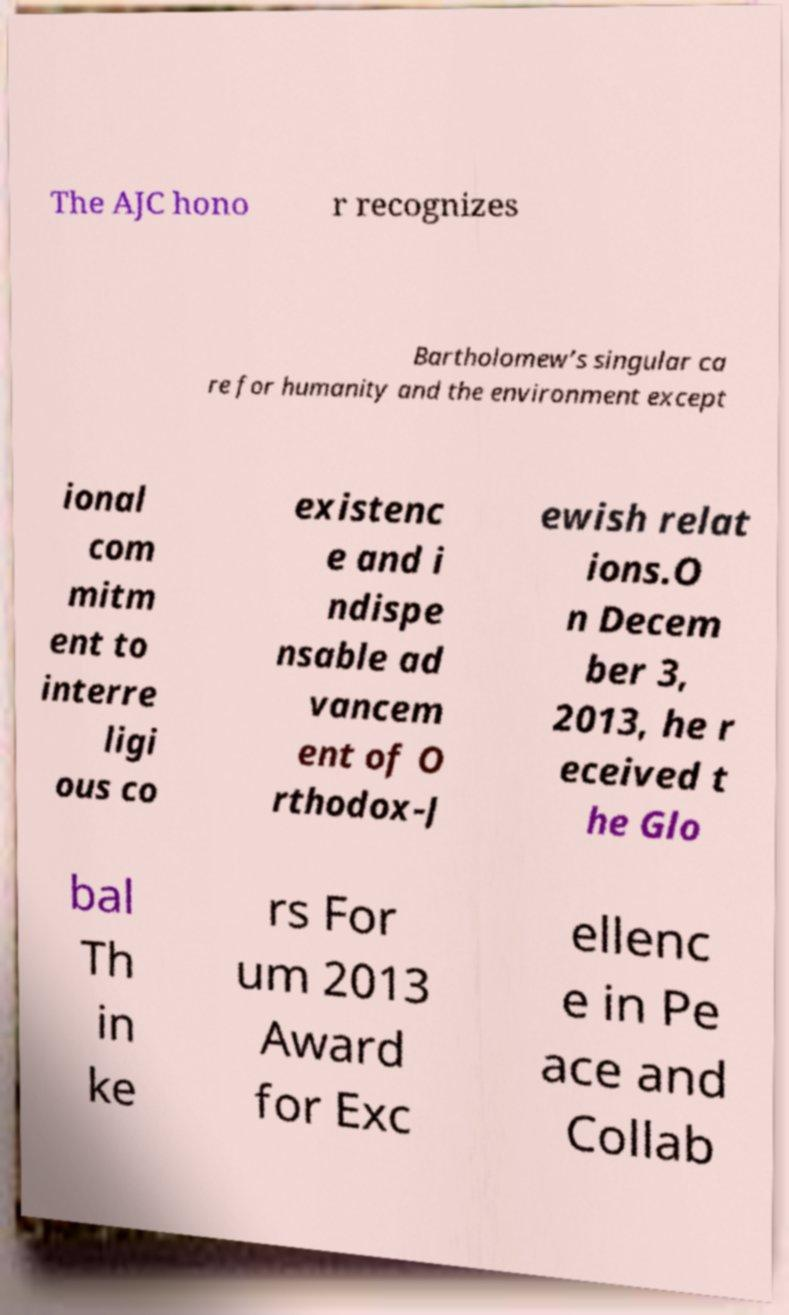Please identify and transcribe the text found in this image. The AJC hono r recognizes Bartholomew’s singular ca re for humanity and the environment except ional com mitm ent to interre ligi ous co existenc e and i ndispe nsable ad vancem ent of O rthodox-J ewish relat ions.O n Decem ber 3, 2013, he r eceived t he Glo bal Th in ke rs For um 2013 Award for Exc ellenc e in Pe ace and Collab 